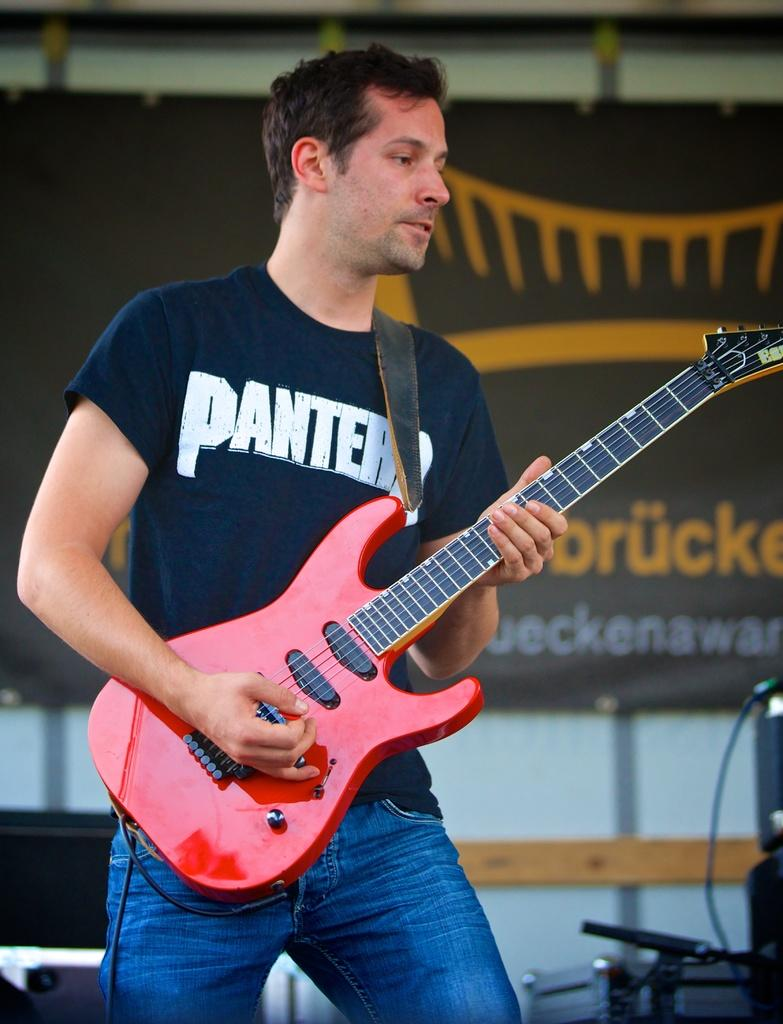Who is in the image? There is a man in the image. What is the man doing? The man is standing. What is the man holding in the image? The man is holding a guitar. Can you describe the guitar? The guitar is red and black in color. What can be seen in the background of the image? There are equipment visible in the background of the image. What type of comfort can be seen in the image? There is no reference to comfort in the image; it features a man holding a red and black guitar while standing. How many owls are present in the image? There are no owls present in the image. 